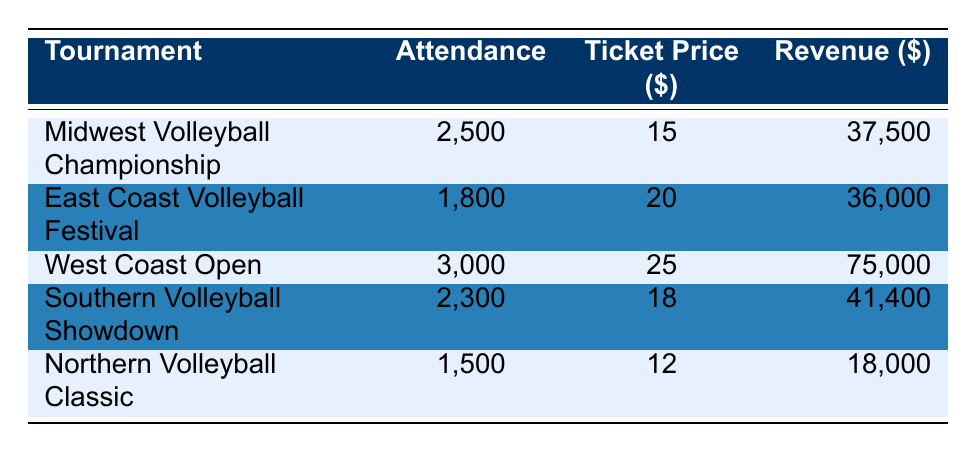What is the revenue for the West Coast Open? From the table, the revenue for the West Coast Open is listed in the last column for that tournament.
Answer: 75000 Which tournament had the highest attendance? By comparing the attendance figures for each tournament in the second column, the West Coast Open has the highest attendance at 3000.
Answer: 3000 What is the total attendance across all tournaments? To find the total attendance, add up the individual attendance numbers: 2500 + 1800 + 3000 + 2300 + 1500 = 11100.
Answer: 11100 Was the ticket price for the Southern Volleyball Showdown higher than that for the Northern Volleyball Classic? The ticket price for the Southern Volleyball Showdown is 18, while for the Northern Volleyball Classic it is 12. As 18 is greater than 12, the statement is true.
Answer: Yes What is the average ticket price for all tournaments? The ticket prices are 15, 20, 25, 18, and 12. Adding these gives 90, and there are 5 tournaments, so the average is 90/5 = 18.
Answer: 18 Which tournament generated the least revenue, and what was the amount? By examining the revenue figures, the tournament with the least revenue is the Northern Volleyball Classic with 18000 as listed in the last column.
Answer: 18000 Is the total revenue for the Midwest Volleyball Championship and East Coast Volleyball Festival greater than that for the Southern Volleyball Showdown? The revenues for the Midwest Volleyball Championship (37500) and East Coast Volleyball Festival (36000) total to 73500. The Southern Volleyball Showdown has a revenue of 41400. Since 73500 > 41400, the statement is true.
Answer: Yes How much more revenue did the West Coast Open generate compared to the Northern Volleyball Classic? The revenue for the West Coast Open is 75000 and for the Northern Volleyball Classic is 18000. The difference is calculated as 75000 - 18000 = 57000.
Answer: 57000 What is the location of the East Coast Volleyball Festival? The location is given in the second column of the table for that particular tournament, which is Atlantic City, NJ.
Answer: Atlantic City, NJ 